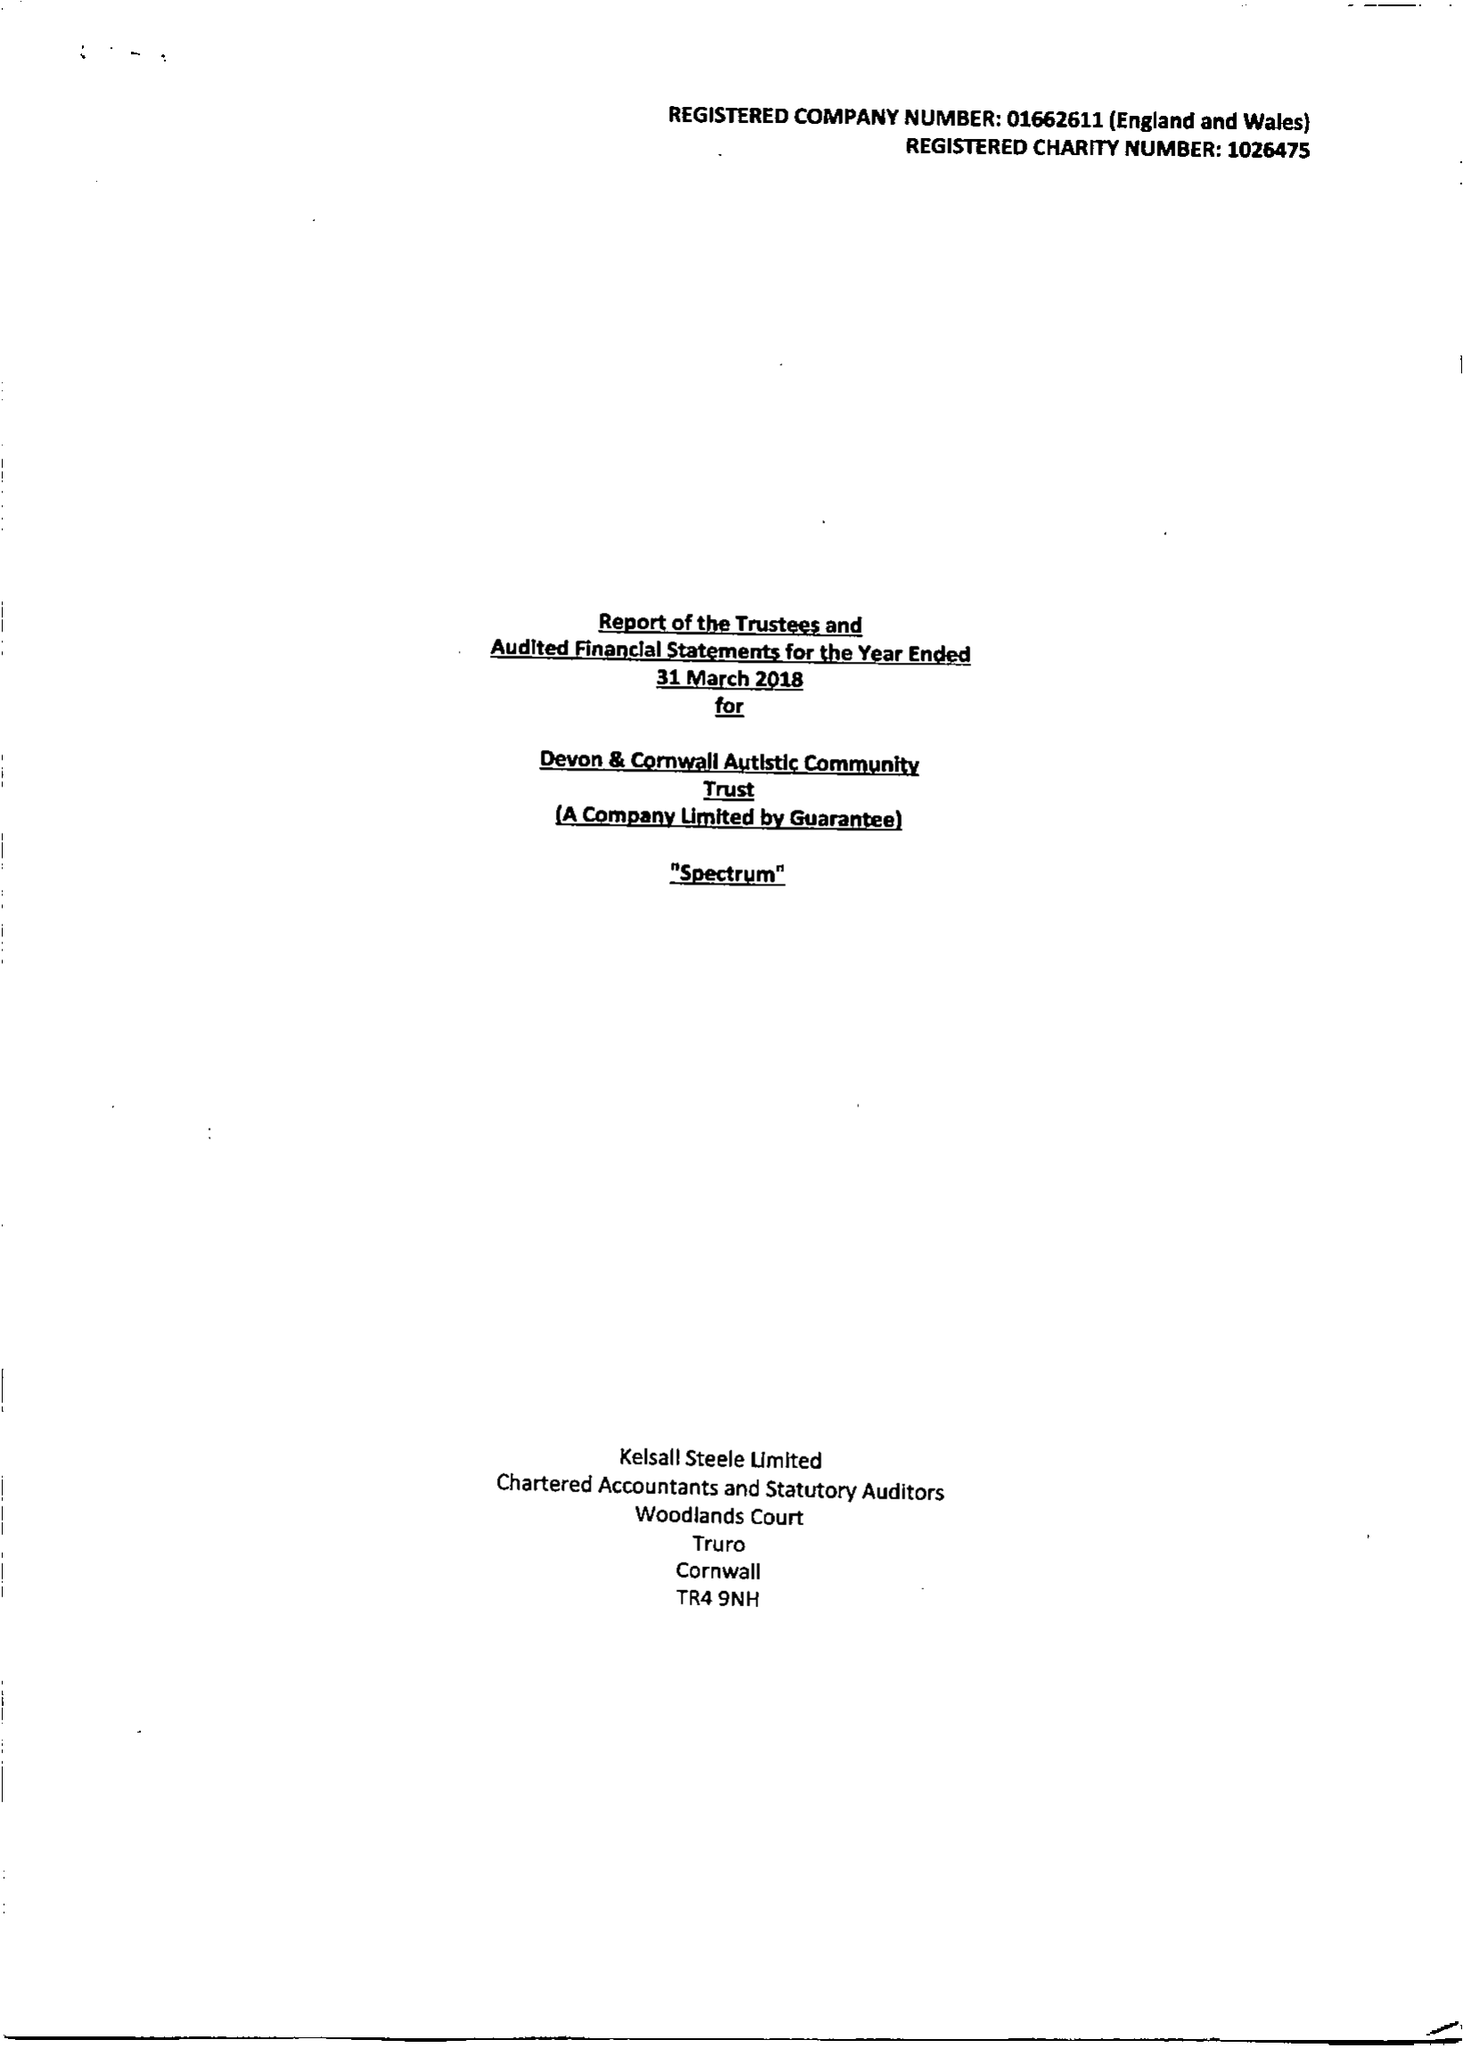What is the value for the charity_name?
Answer the question using a single word or phrase. Devon and Cornwall Autistic Community Trust 